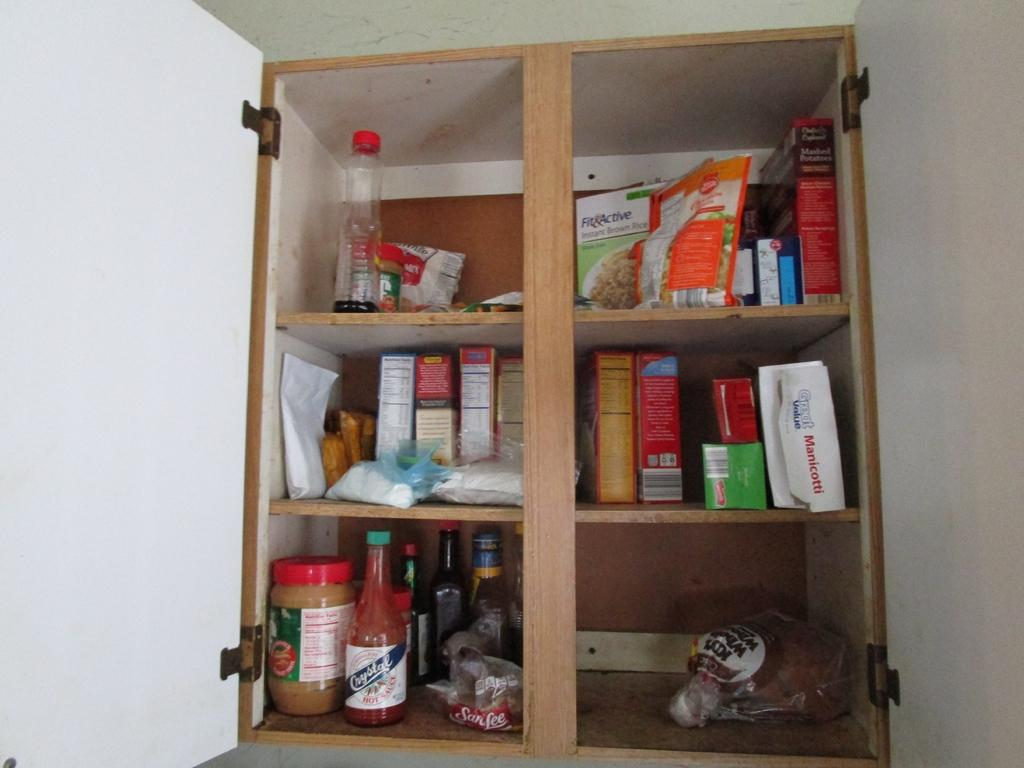<image>
Relay a brief, clear account of the picture shown. An open wooden cabinet with peanut butter and hot sauce in it. 